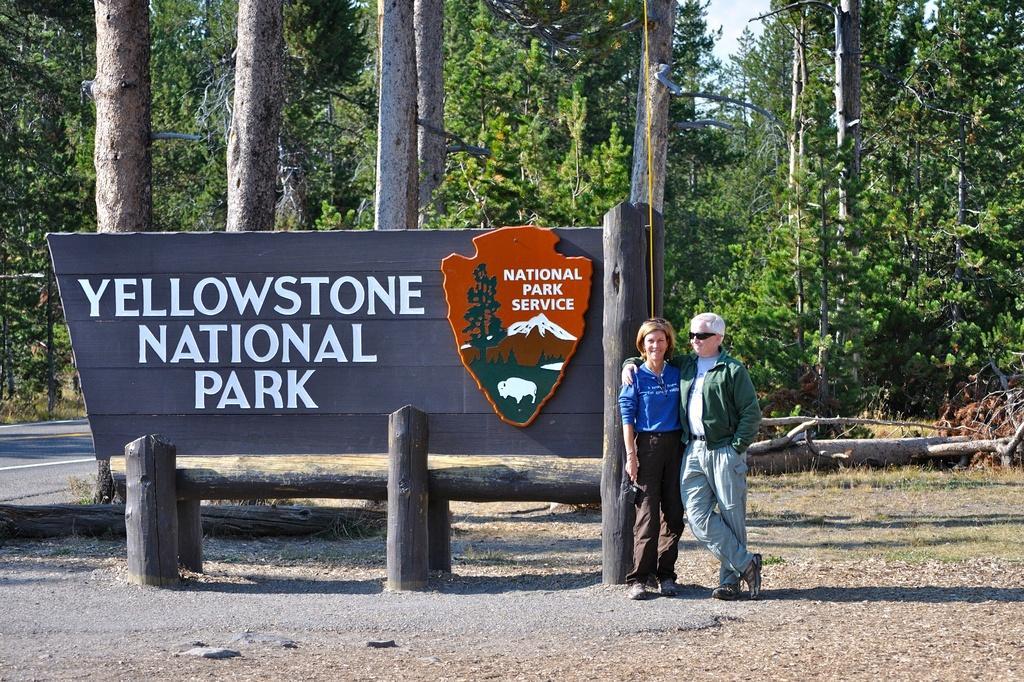Describe this image in one or two sentences. In this picture there are two people standing and there is a board. There is text on the board. At the back there are trees. At the top there is sky. At the bottom there is a road and there is ground. 